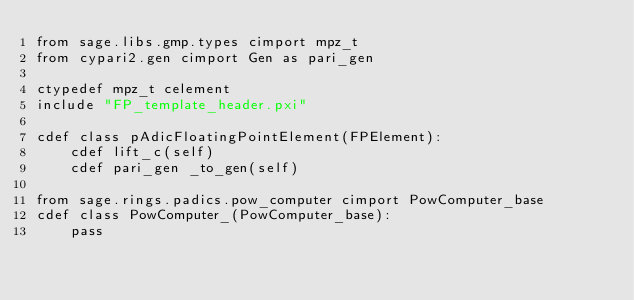<code> <loc_0><loc_0><loc_500><loc_500><_Cython_>from sage.libs.gmp.types cimport mpz_t
from cypari2.gen cimport Gen as pari_gen

ctypedef mpz_t celement
include "FP_template_header.pxi"

cdef class pAdicFloatingPointElement(FPElement):
    cdef lift_c(self)
    cdef pari_gen _to_gen(self)

from sage.rings.padics.pow_computer cimport PowComputer_base
cdef class PowComputer_(PowComputer_base):
    pass
</code> 